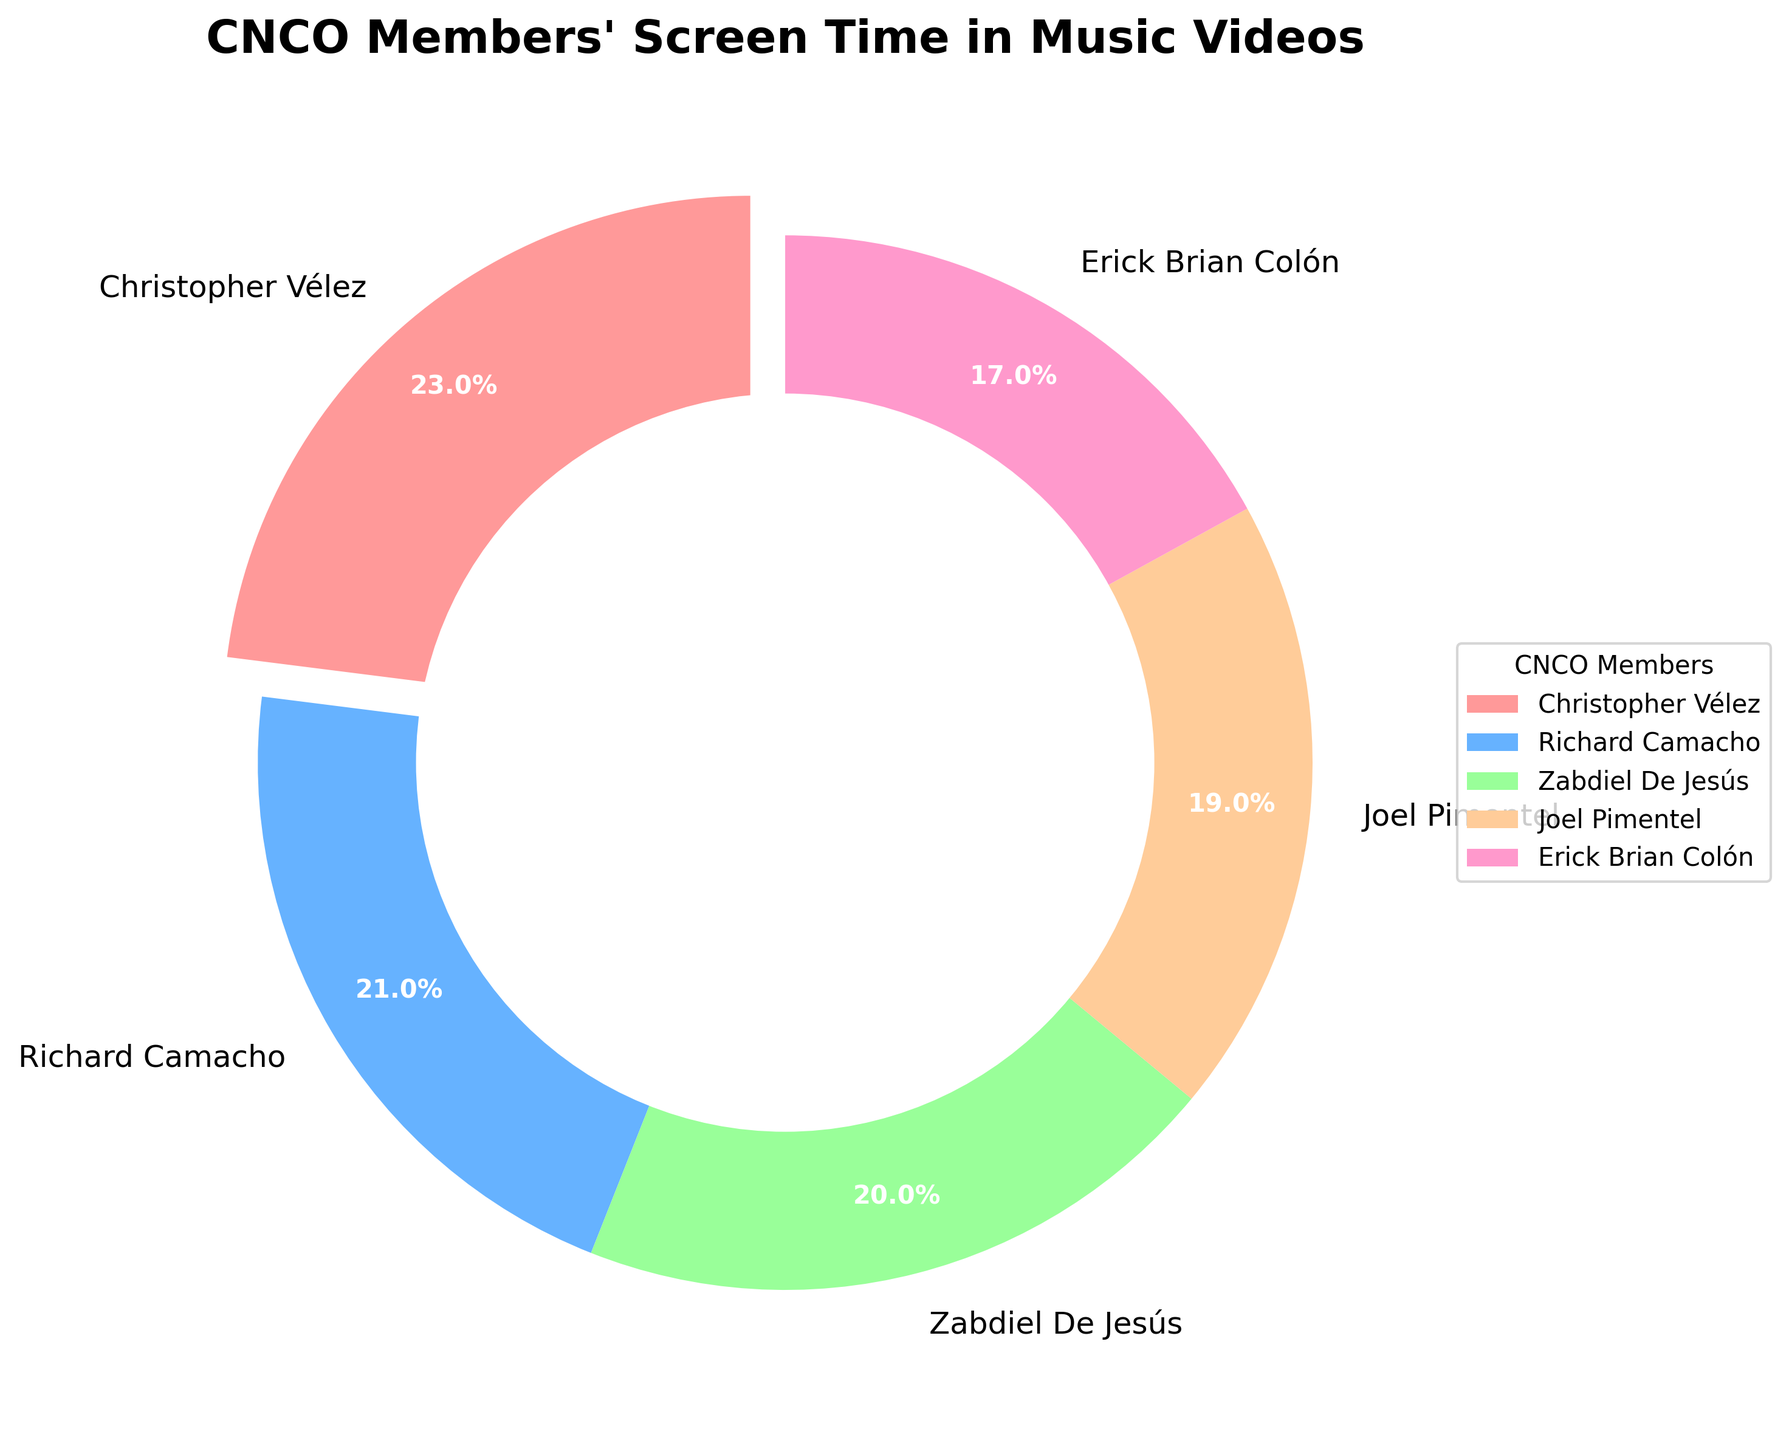Which CNCO member has the highest screen time percentage in their music videos? The member with the highest percentage slice in the pie chart is the one with the highest screen time percentage. Christopher Vélez has the largest slice.
Answer: Christopher Vélez Which CNCO member has the lowest screen time percentage in their music videos? The member with the smallest percentage slice in the pie chart is the one with the lowest screen time percentage. Erick Brian Colón has the smallest slice.
Answer: Erick Brian Colón What's the total screen time percentage of Richard Camacho and Joel Pimentel combined? Add the screen time percentages of Richard Camacho and Joel Pimentel: 21% + 19% = 40%
Answer: 40% Who has more screen time, Zabdiel De Jesús or Erick Brian Colón, and by how much? Zabdiel De Jesús has 20% and Erick Brian Colón has 17%. The difference is 20% - 17% = 3%.
Answer: Zabdiel De Jesús by 3% Compare the screen time of Christopher Vélez and the sum of Zabdiel De Jesús and Erick Brian Colón. Who has more, and by how much? The sum of Zabdiel De Jesús and Erick Brian Colón is 20% + 17% = 37%. Christopher Vélez has 23%. 37% - 23% = 14%, so the sum of the two members is greater by 14%.
Answer: Sum of Zabdiel and Erick by 14% What percentage of screen time does the majority of the members together hold in total? Sum the screen time percentages of the top three members: Christopher Vélez (23%), Richard Camacho (21%), and Zabdiel De Jesús (20%). 23% + 21% + 20% = 64%
Answer: 64% Which member's screen time percentage is closest to the average screen time percentage of all members? Calculate the average screen time: (23% + 21% + 20% + 19% + 17%) / 5 = 20%. Zabdiel De Jesús has a screen time percentage of 20%, which matches the average.
Answer: Zabdiel De Jesús Identify the color associated with Erick Brian Colón's screen time in the pie chart. Erick Brian Colón's slice is colored pink in the pie chart.
Answer: Pink If you combined the screen time of Richard Camacho and Joel Pimentel, would their combined screen time be greater than Christopher Vélez's? Richard Camacho (21%) + Joel Pimentel (19%) = 40%, which is greater than Christopher Vélez's 23%.
Answer: Yes 